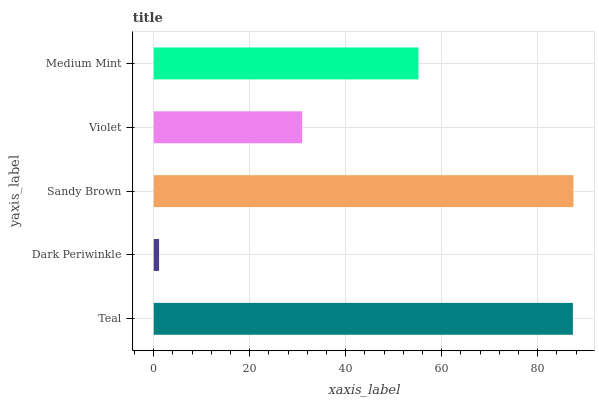Is Dark Periwinkle the minimum?
Answer yes or no. Yes. Is Sandy Brown the maximum?
Answer yes or no. Yes. Is Sandy Brown the minimum?
Answer yes or no. No. Is Dark Periwinkle the maximum?
Answer yes or no. No. Is Sandy Brown greater than Dark Periwinkle?
Answer yes or no. Yes. Is Dark Periwinkle less than Sandy Brown?
Answer yes or no. Yes. Is Dark Periwinkle greater than Sandy Brown?
Answer yes or no. No. Is Sandy Brown less than Dark Periwinkle?
Answer yes or no. No. Is Medium Mint the high median?
Answer yes or no. Yes. Is Medium Mint the low median?
Answer yes or no. Yes. Is Sandy Brown the high median?
Answer yes or no. No. Is Sandy Brown the low median?
Answer yes or no. No. 